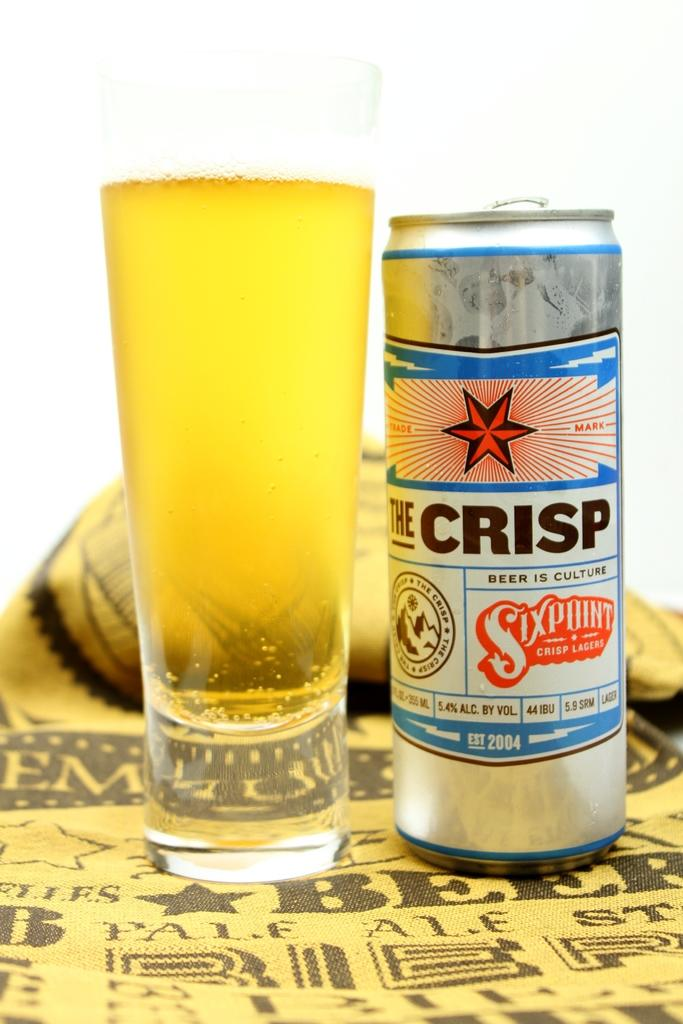<image>
Present a compact description of the photo's key features. A silver beer can says The Crisp and is next to a full glass. 